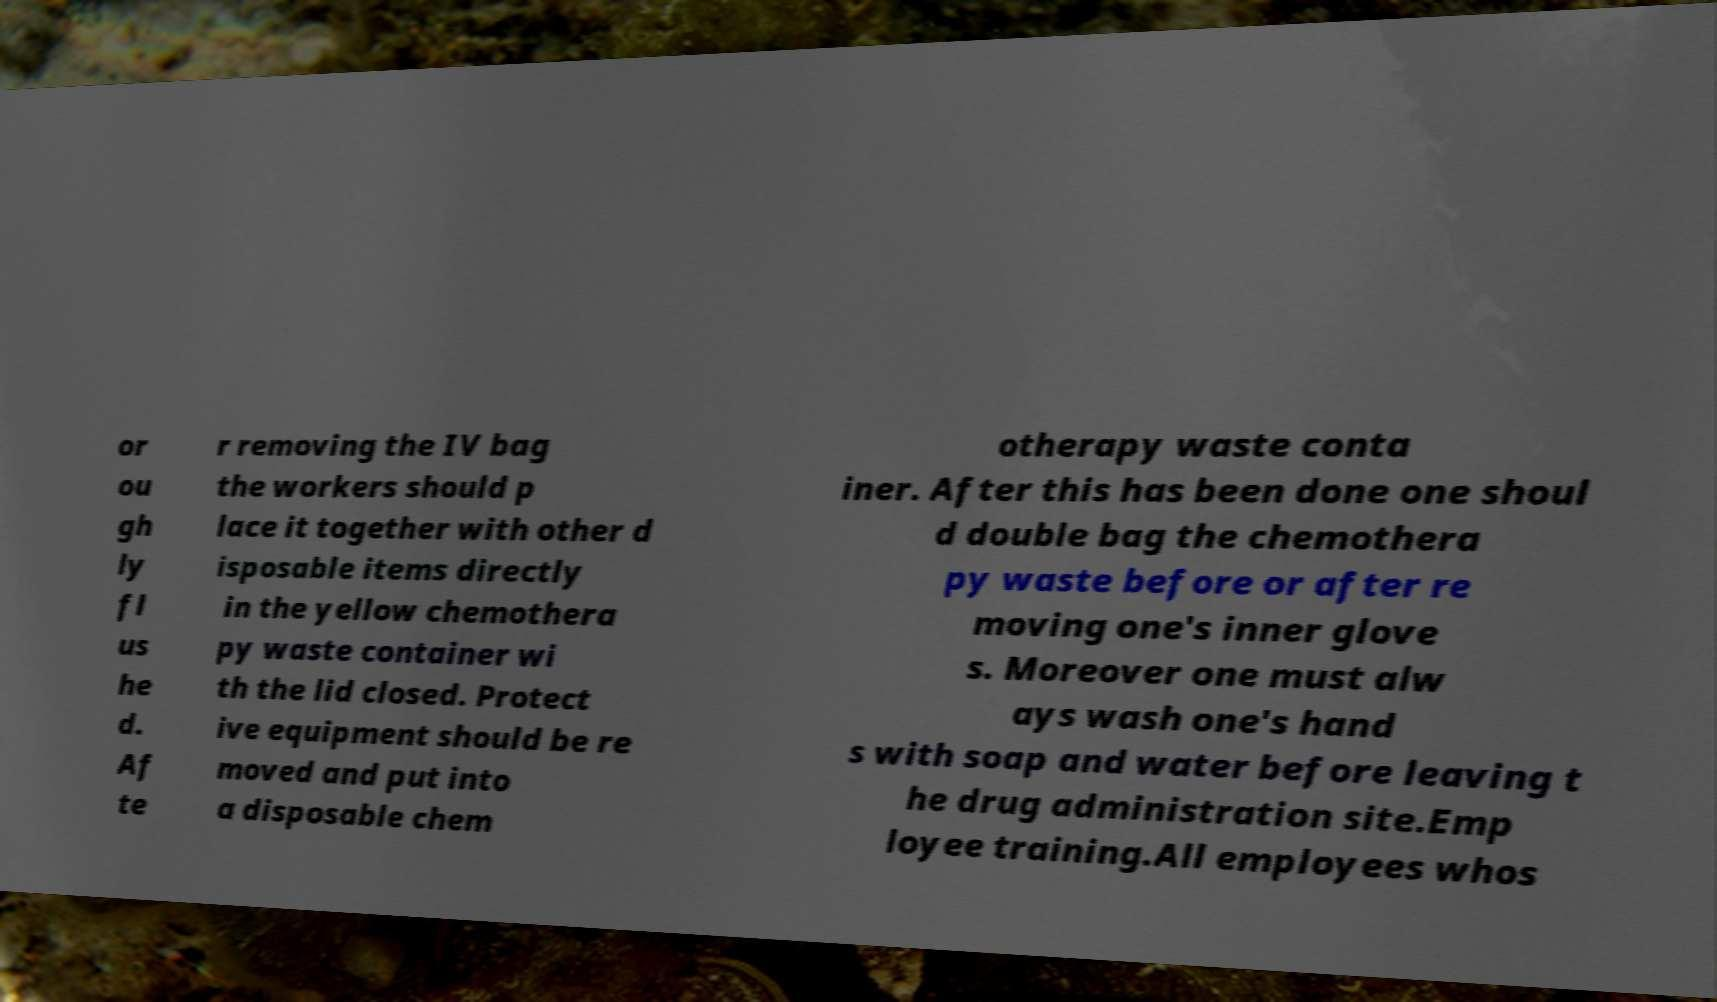Please identify and transcribe the text found in this image. or ou gh ly fl us he d. Af te r removing the IV bag the workers should p lace it together with other d isposable items directly in the yellow chemothera py waste container wi th the lid closed. Protect ive equipment should be re moved and put into a disposable chem otherapy waste conta iner. After this has been done one shoul d double bag the chemothera py waste before or after re moving one's inner glove s. Moreover one must alw ays wash one's hand s with soap and water before leaving t he drug administration site.Emp loyee training.All employees whos 